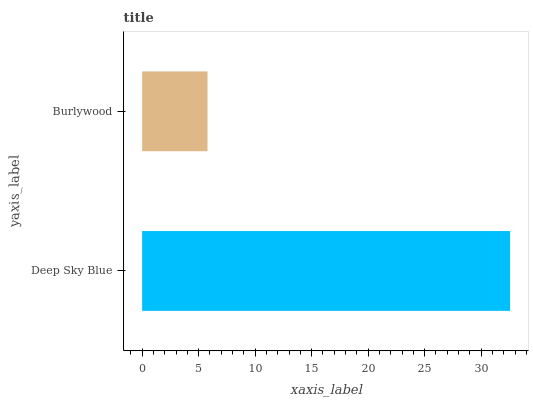Is Burlywood the minimum?
Answer yes or no. Yes. Is Deep Sky Blue the maximum?
Answer yes or no. Yes. Is Burlywood the maximum?
Answer yes or no. No. Is Deep Sky Blue greater than Burlywood?
Answer yes or no. Yes. Is Burlywood less than Deep Sky Blue?
Answer yes or no. Yes. Is Burlywood greater than Deep Sky Blue?
Answer yes or no. No. Is Deep Sky Blue less than Burlywood?
Answer yes or no. No. Is Deep Sky Blue the high median?
Answer yes or no. Yes. Is Burlywood the low median?
Answer yes or no. Yes. Is Burlywood the high median?
Answer yes or no. No. Is Deep Sky Blue the low median?
Answer yes or no. No. 